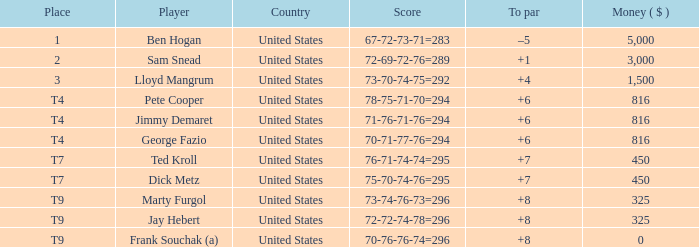What sum was awarded to the participant who achieved 70-71-77-76=294? 816.0. 